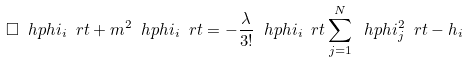Convert formula to latex. <formula><loc_0><loc_0><loc_500><loc_500>\Box \ h p h i _ { i } \ r t + m ^ { 2 } \ h p h i _ { i } \ r t = - \frac { \lambda } { 3 ! } \ h p h i _ { i } \ r t \sum _ { j = 1 } ^ { N } \ h p h i _ { j } ^ { 2 } \ r t - h _ { i }</formula> 